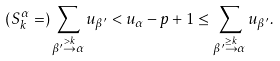<formula> <loc_0><loc_0><loc_500><loc_500>( S _ { k } ^ { \alpha } = ) \sum _ { \beta ^ { \prime } \stackrel { > k } { \to } \alpha } u _ { \beta ^ { \prime } } < u _ { \alpha } - p + 1 \leq \sum _ { \beta ^ { \prime } \stackrel { \geq k } { \to } \alpha } u _ { \beta ^ { \prime } } .</formula> 